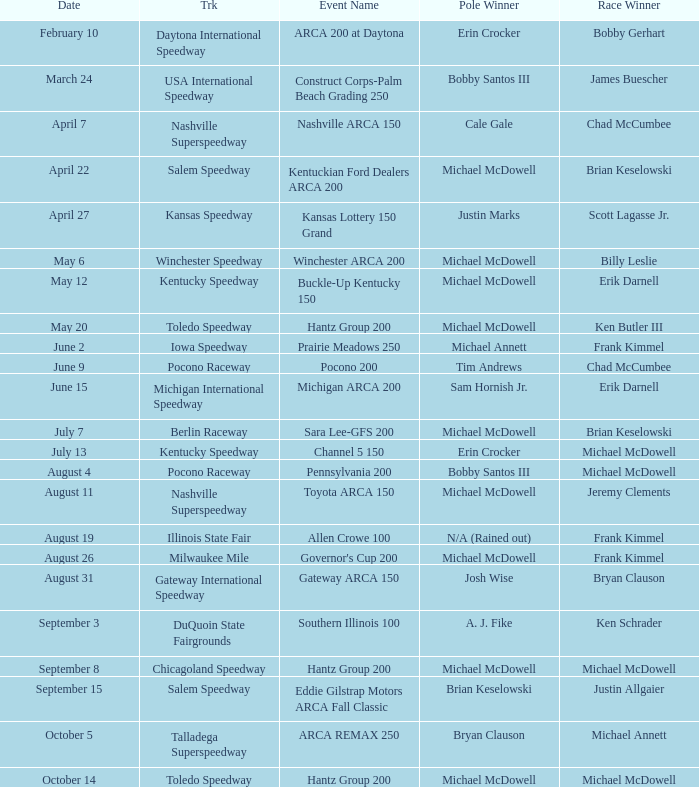Tell me the pole winner of may 12 Michael McDowell. 